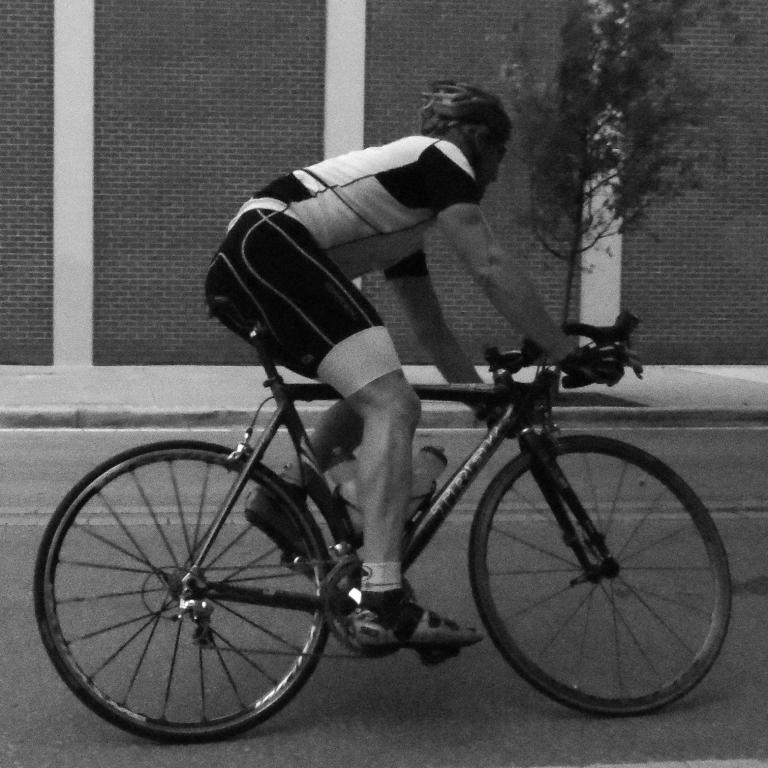What is the main subject of the image? There is a person in the image. What is the person doing in the image? The person is riding a bicycle. What can be seen in the background of the image? There is a plant behind the person. What type of advertisement can be seen on the person's shirt in the image? There is no advertisement visible on the person's shirt in the image. What type of cushion is the person sitting on while riding the bicycle? The person is not sitting on a cushion while riding the bicycle; they are riding a standard bicycle. 